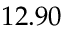Convert formula to latex. <formula><loc_0><loc_0><loc_500><loc_500>1 2 . 9 0</formula> 